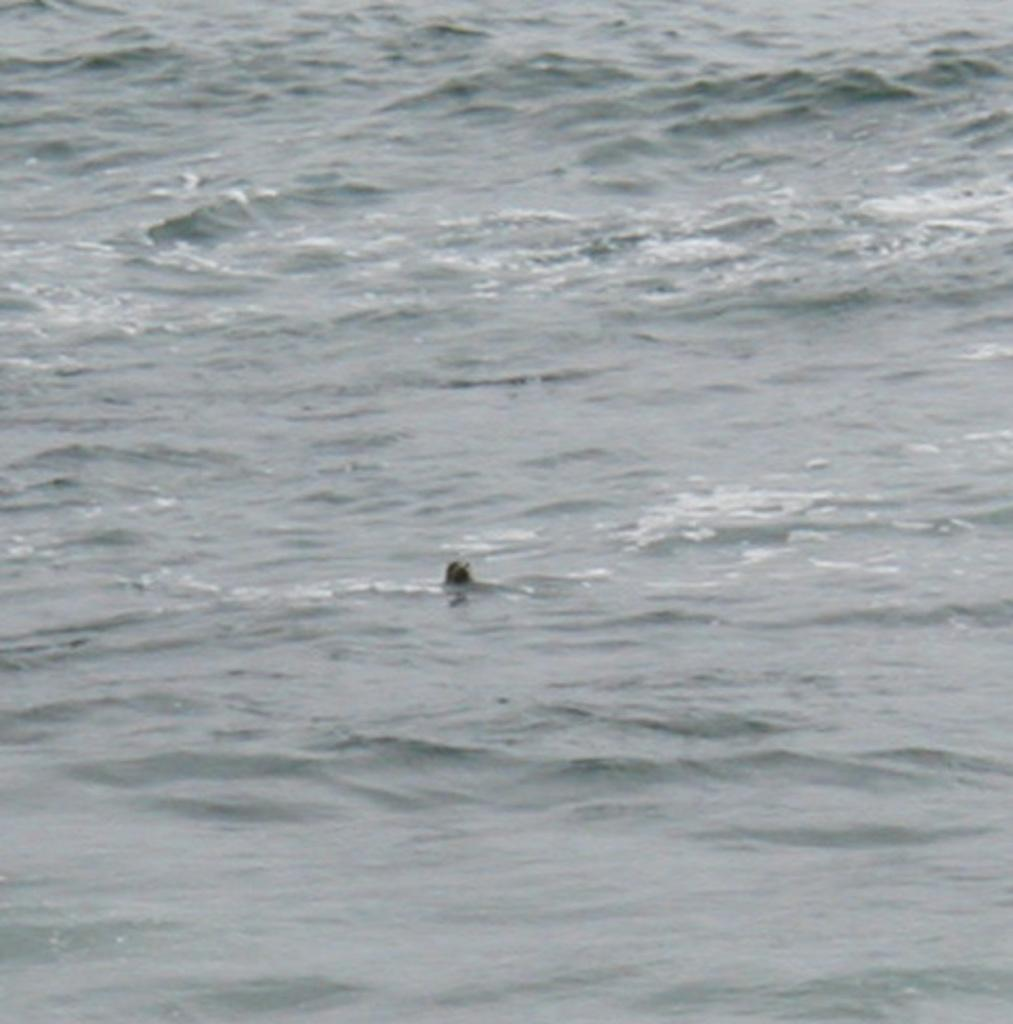What is the main subject of the image? The main subject of the image is an unspecified object in the water. What can be seen in the background of the image? The background of the image includes water. What type of curtain can be seen hanging in the water in the image? There is no curtain present in the image; it features an unspecified object in the water. What kind of art is displayed on the wall behind the water in the image? There is no wall or art visible in the image, as it only shows an unspecified object in the water. 